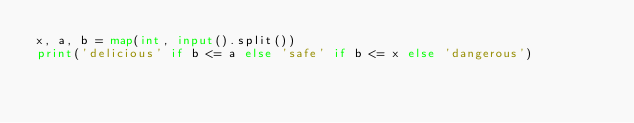Convert code to text. <code><loc_0><loc_0><loc_500><loc_500><_Python_>x, a, b = map(int, input().split())
print('delicious' if b <= a else 'safe' if b <= x else 'dangerous')</code> 